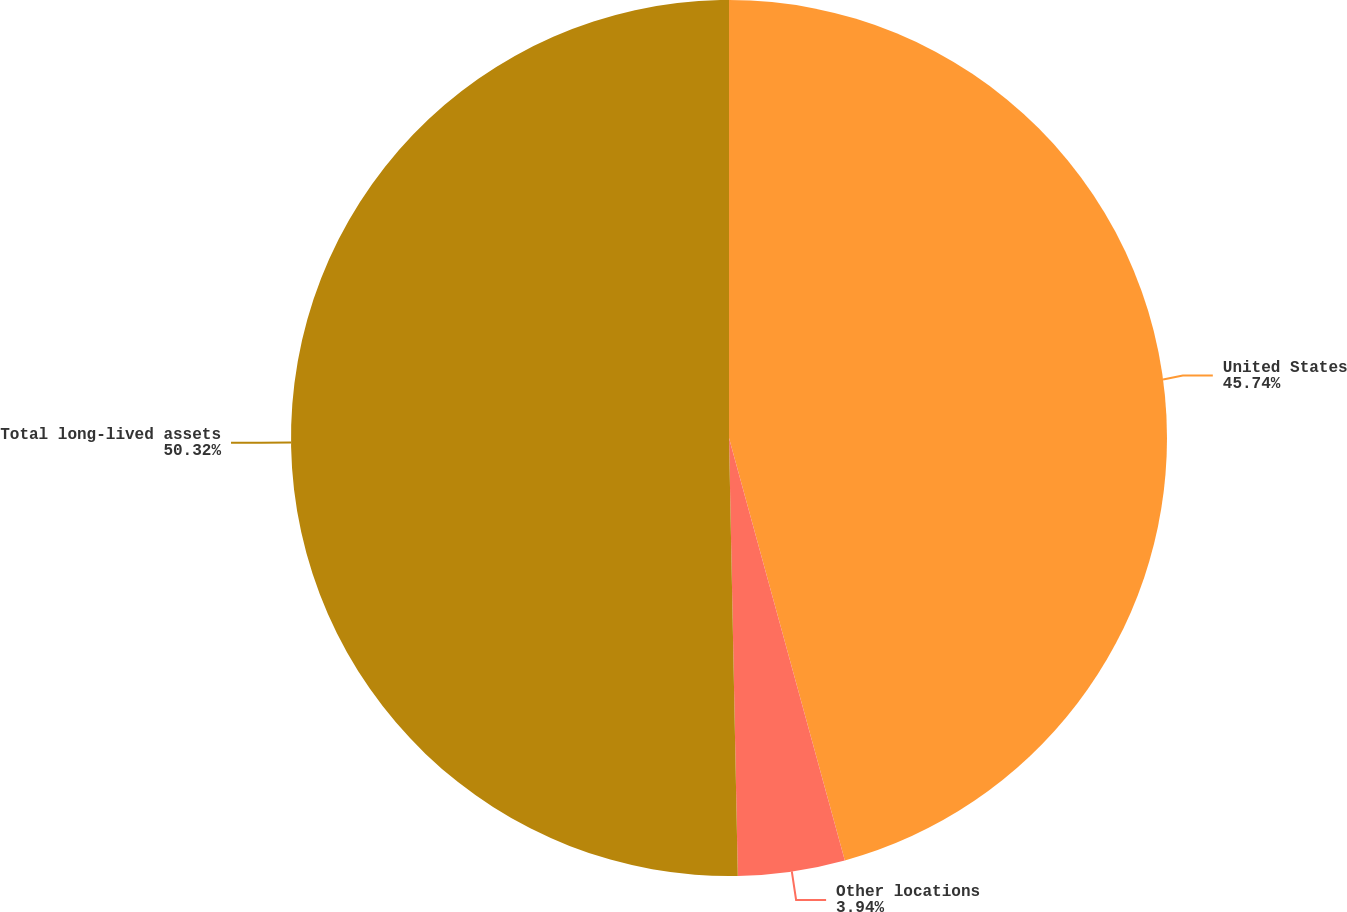Convert chart. <chart><loc_0><loc_0><loc_500><loc_500><pie_chart><fcel>United States<fcel>Other locations<fcel>Total long-lived assets<nl><fcel>45.74%<fcel>3.94%<fcel>50.32%<nl></chart> 